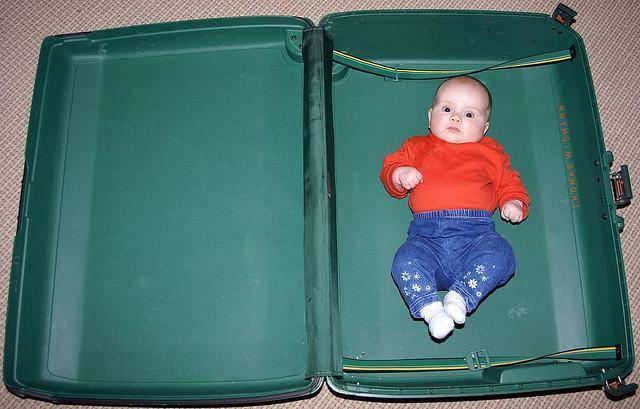How many people are in the picture?
Give a very brief answer. 1. 